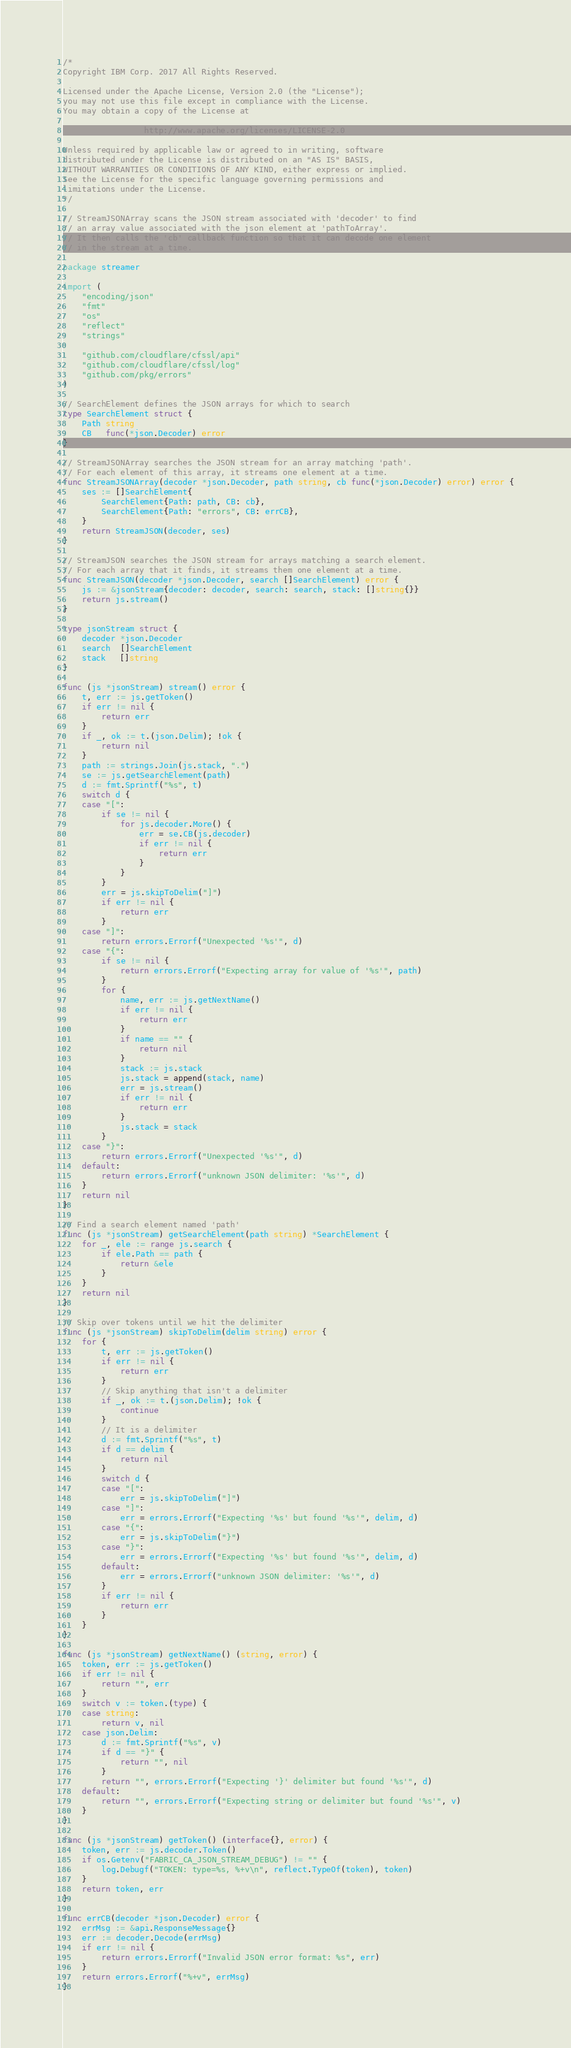Convert code to text. <code><loc_0><loc_0><loc_500><loc_500><_Go_>/*
Copyright IBM Corp. 2017 All Rights Reserved.

Licensed under the Apache License, Version 2.0 (the "License");
you may not use this file except in compliance with the License.
You may obtain a copy of the License at

                 http://www.apache.org/licenses/LICENSE-2.0

Unless required by applicable law or agreed to in writing, software
distributed under the License is distributed on an "AS IS" BASIS,
WITHOUT WARRANTIES OR CONDITIONS OF ANY KIND, either express or implied.
See the License for the specific language governing permissions and
limitations under the License.
*/

// StreamJSONArray scans the JSON stream associated with 'decoder' to find
// an array value associated with the json element at 'pathToArray'.
// It then calls the 'cb' callback function so that it can decode one element
// in the stream at a time.

package streamer

import (
	"encoding/json"
	"fmt"
	"os"
	"reflect"
	"strings"

	"github.com/cloudflare/cfssl/api"
	"github.com/cloudflare/cfssl/log"
	"github.com/pkg/errors"
)

// SearchElement defines the JSON arrays for which to search
type SearchElement struct {
	Path string
	CB   func(*json.Decoder) error
}

// StreamJSONArray searches the JSON stream for an array matching 'path'.
// For each element of this array, it streams one element at a time.
func StreamJSONArray(decoder *json.Decoder, path string, cb func(*json.Decoder) error) error {
	ses := []SearchElement{
		SearchElement{Path: path, CB: cb},
		SearchElement{Path: "errors", CB: errCB},
	}
	return StreamJSON(decoder, ses)
}

// StreamJSON searches the JSON stream for arrays matching a search element.
// For each array that it finds, it streams them one element at a time.
func StreamJSON(decoder *json.Decoder, search []SearchElement) error {
	js := &jsonStream{decoder: decoder, search: search, stack: []string{}}
	return js.stream()
}

type jsonStream struct {
	decoder *json.Decoder
	search  []SearchElement
	stack   []string
}

func (js *jsonStream) stream() error {
	t, err := js.getToken()
	if err != nil {
		return err
	}
	if _, ok := t.(json.Delim); !ok {
		return nil
	}
	path := strings.Join(js.stack, ".")
	se := js.getSearchElement(path)
	d := fmt.Sprintf("%s", t)
	switch d {
	case "[":
		if se != nil {
			for js.decoder.More() {
				err = se.CB(js.decoder)
				if err != nil {
					return err
				}
			}
		}
		err = js.skipToDelim("]")
		if err != nil {
			return err
		}
	case "]":
		return errors.Errorf("Unexpected '%s'", d)
	case "{":
		if se != nil {
			return errors.Errorf("Expecting array for value of '%s'", path)
		}
		for {
			name, err := js.getNextName()
			if err != nil {
				return err
			}
			if name == "" {
				return nil
			}
			stack := js.stack
			js.stack = append(stack, name)
			err = js.stream()
			if err != nil {
				return err
			}
			js.stack = stack
		}
	case "}":
		return errors.Errorf("Unexpected '%s'", d)
	default:
		return errors.Errorf("unknown JSON delimiter: '%s'", d)
	}
	return nil
}

// Find a search element named 'path'
func (js *jsonStream) getSearchElement(path string) *SearchElement {
	for _, ele := range js.search {
		if ele.Path == path {
			return &ele
		}
	}
	return nil
}

// Skip over tokens until we hit the delimiter
func (js *jsonStream) skipToDelim(delim string) error {
	for {
		t, err := js.getToken()
		if err != nil {
			return err
		}
		// Skip anything that isn't a delimiter
		if _, ok := t.(json.Delim); !ok {
			continue
		}
		// It is a delimiter
		d := fmt.Sprintf("%s", t)
		if d == delim {
			return nil
		}
		switch d {
		case "[":
			err = js.skipToDelim("]")
		case "]":
			err = errors.Errorf("Expecting '%s' but found '%s'", delim, d)
		case "{":
			err = js.skipToDelim("}")
		case "}":
			err = errors.Errorf("Expecting '%s' but found '%s'", delim, d)
		default:
			err = errors.Errorf("unknown JSON delimiter: '%s'", d)
		}
		if err != nil {
			return err
		}
	}
}

func (js *jsonStream) getNextName() (string, error) {
	token, err := js.getToken()
	if err != nil {
		return "", err
	}
	switch v := token.(type) {
	case string:
		return v, nil
	case json.Delim:
		d := fmt.Sprintf("%s", v)
		if d == "}" {
			return "", nil
		}
		return "", errors.Errorf("Expecting '}' delimiter but found '%s'", d)
	default:
		return "", errors.Errorf("Expecting string or delimiter but found '%s'", v)
	}
}

func (js *jsonStream) getToken() (interface{}, error) {
	token, err := js.decoder.Token()
	if os.Getenv("FABRIC_CA_JSON_STREAM_DEBUG") != "" {
		log.Debugf("TOKEN: type=%s, %+v\n", reflect.TypeOf(token), token)
	}
	return token, err
}

func errCB(decoder *json.Decoder) error {
	errMsg := &api.ResponseMessage{}
	err := decoder.Decode(errMsg)
	if err != nil {
		return errors.Errorf("Invalid JSON error format: %s", err)
	}
	return errors.Errorf("%+v", errMsg)
}
</code> 